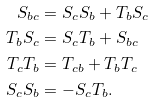Convert formula to latex. <formula><loc_0><loc_0><loc_500><loc_500>S _ { b c } & = S _ { c } S _ { b } + T _ { b } S _ { c } \\ T _ { b } S _ { c } & = S _ { c } T _ { b } + S _ { b c } \\ T _ { c } T _ { b } & = T _ { c b } + T _ { b } T _ { c } \\ S _ { c } S _ { b } & = - S _ { c } T _ { b } .</formula> 